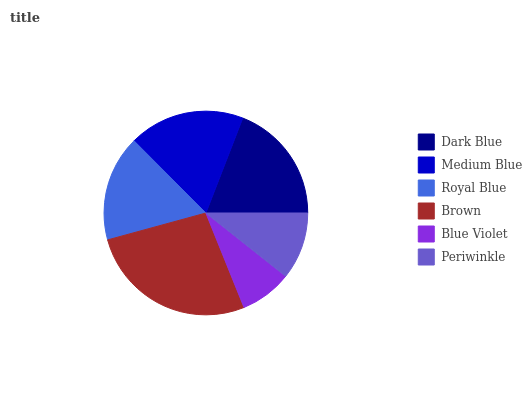Is Blue Violet the minimum?
Answer yes or no. Yes. Is Brown the maximum?
Answer yes or no. Yes. Is Medium Blue the minimum?
Answer yes or no. No. Is Medium Blue the maximum?
Answer yes or no. No. Is Dark Blue greater than Medium Blue?
Answer yes or no. Yes. Is Medium Blue less than Dark Blue?
Answer yes or no. Yes. Is Medium Blue greater than Dark Blue?
Answer yes or no. No. Is Dark Blue less than Medium Blue?
Answer yes or no. No. Is Medium Blue the high median?
Answer yes or no. Yes. Is Royal Blue the low median?
Answer yes or no. Yes. Is Dark Blue the high median?
Answer yes or no. No. Is Brown the low median?
Answer yes or no. No. 